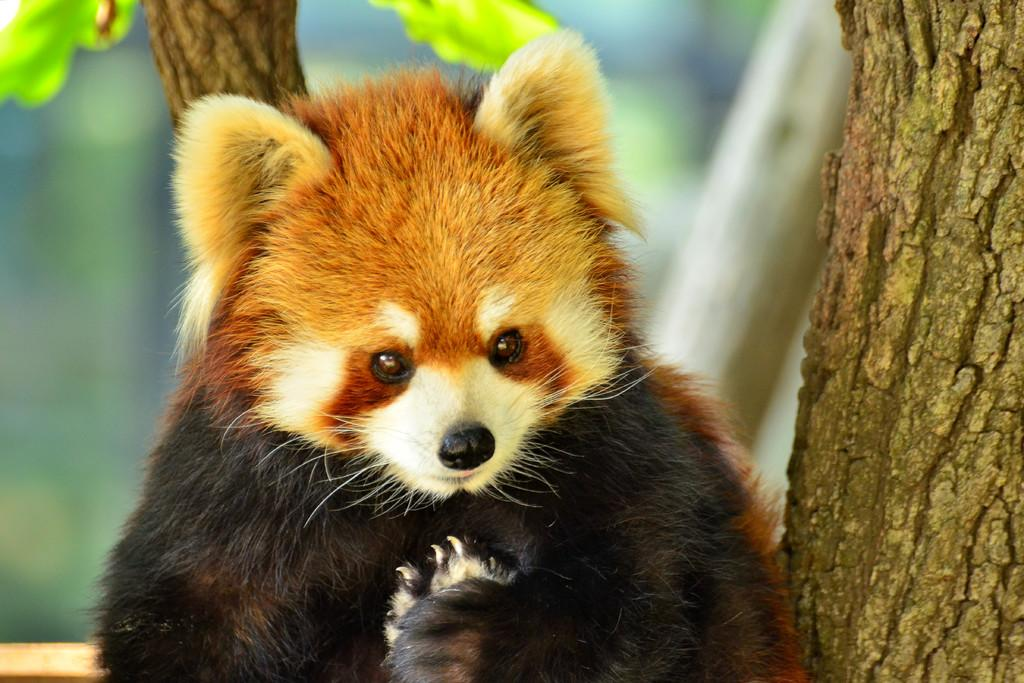What is the main subject in the foreground of the image? There is an animal in the foreground of the image. What can be seen in the background of the image? There is a tree in the background of the image. How would you describe the background of the image? The background appears blurry. What type of rice is being harvested in the field in the image? There is no field or rice present in the image; it features an animal and a tree in the background. 